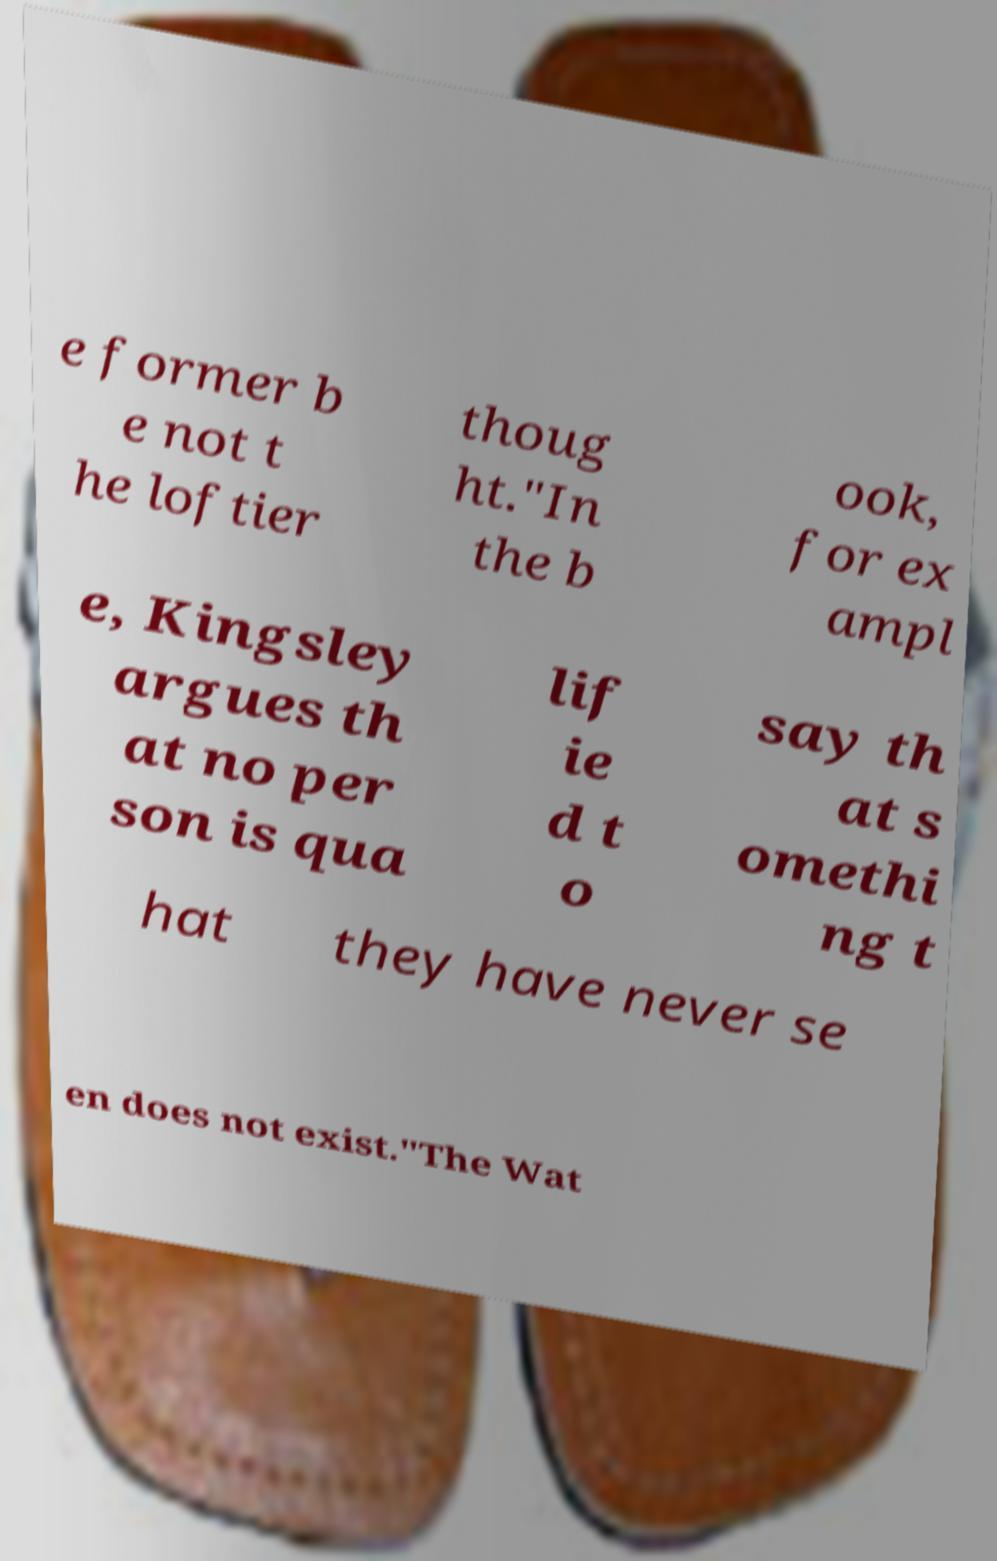Can you read and provide the text displayed in the image?This photo seems to have some interesting text. Can you extract and type it out for me? e former b e not t he loftier thoug ht."In the b ook, for ex ampl e, Kingsley argues th at no per son is qua lif ie d t o say th at s omethi ng t hat they have never se en does not exist."The Wat 